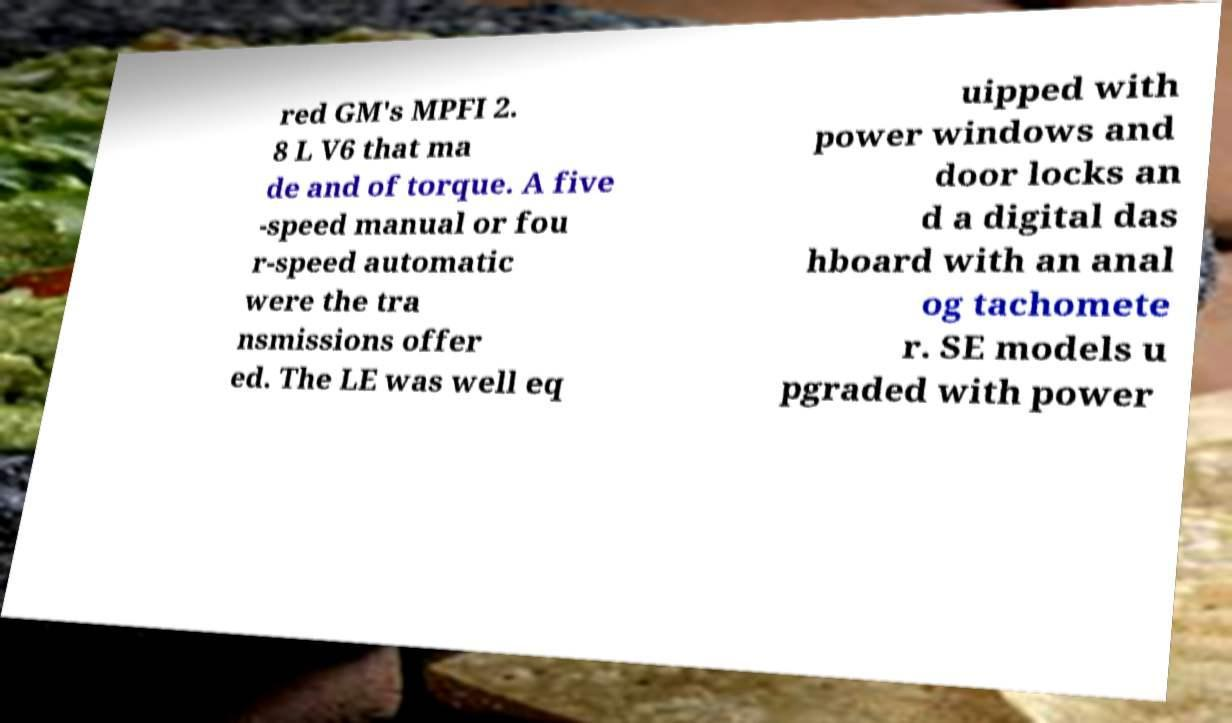Could you assist in decoding the text presented in this image and type it out clearly? red GM's MPFI 2. 8 L V6 that ma de and of torque. A five -speed manual or fou r-speed automatic were the tra nsmissions offer ed. The LE was well eq uipped with power windows and door locks an d a digital das hboard with an anal og tachomete r. SE models u pgraded with power 